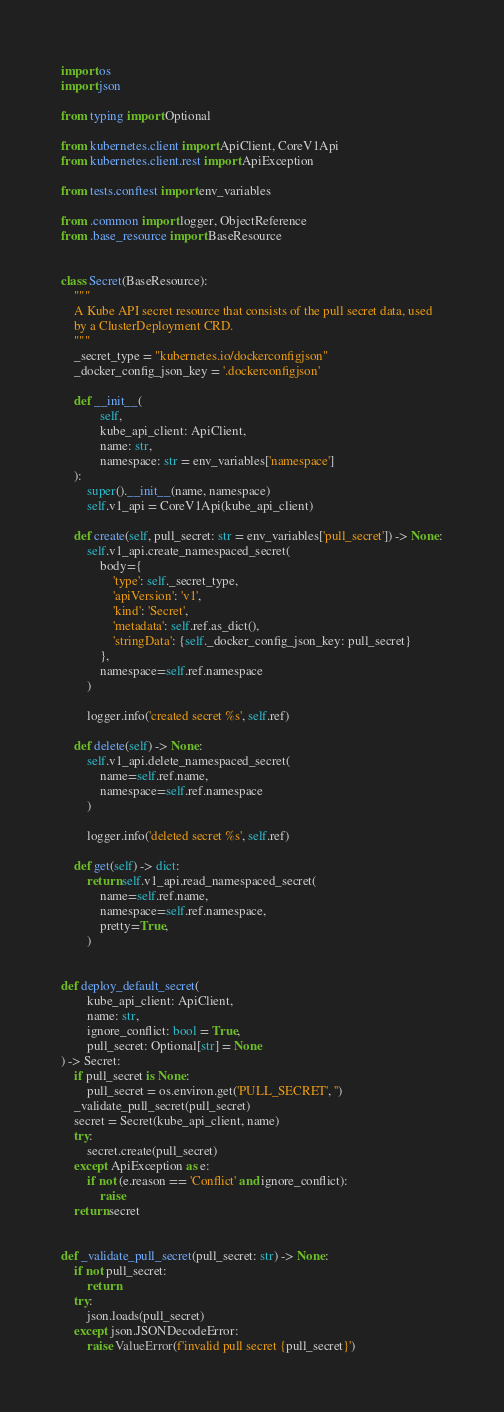Convert code to text. <code><loc_0><loc_0><loc_500><loc_500><_Python_>import os
import json

from typing import Optional

from kubernetes.client import ApiClient, CoreV1Api
from kubernetes.client.rest import ApiException

from tests.conftest import env_variables

from .common import logger, ObjectReference
from .base_resource import BaseResource


class Secret(BaseResource):
    """
    A Kube API secret resource that consists of the pull secret data, used
    by a ClusterDeployment CRD.
    """
    _secret_type = "kubernetes.io/dockerconfigjson"
    _docker_config_json_key = '.dockerconfigjson'

    def __init__(
            self,
            kube_api_client: ApiClient,
            name: str,
            namespace: str = env_variables['namespace']
    ):
        super().__init__(name, namespace)
        self.v1_api = CoreV1Api(kube_api_client)

    def create(self, pull_secret: str = env_variables['pull_secret']) -> None:
        self.v1_api.create_namespaced_secret(
            body={
                'type': self._secret_type,
                'apiVersion': 'v1',
                'kind': 'Secret',
                'metadata': self.ref.as_dict(),
                'stringData': {self._docker_config_json_key: pull_secret}
            },
            namespace=self.ref.namespace
        )

        logger.info('created secret %s', self.ref)

    def delete(self) -> None:
        self.v1_api.delete_namespaced_secret(
            name=self.ref.name,
            namespace=self.ref.namespace
        )

        logger.info('deleted secret %s', self.ref)

    def get(self) -> dict:
        return self.v1_api.read_namespaced_secret(
            name=self.ref.name,
            namespace=self.ref.namespace,
            pretty=True,
        )


def deploy_default_secret(
        kube_api_client: ApiClient,
        name: str,
        ignore_conflict: bool = True,
        pull_secret: Optional[str] = None
) -> Secret:
    if pull_secret is None:
        pull_secret = os.environ.get('PULL_SECRET', '')
    _validate_pull_secret(pull_secret)
    secret = Secret(kube_api_client, name)
    try:
        secret.create(pull_secret)
    except ApiException as e:
        if not (e.reason == 'Conflict' and ignore_conflict):
            raise
    return secret


def _validate_pull_secret(pull_secret: str) -> None:
    if not pull_secret:
        return
    try:
        json.loads(pull_secret)
    except json.JSONDecodeError:
        raise ValueError(f'invalid pull secret {pull_secret}')
</code> 